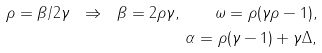<formula> <loc_0><loc_0><loc_500><loc_500>\rho = \beta / 2 \gamma \ \Rightarrow \ \beta = 2 \rho \gamma , \quad \omega = \rho ( \gamma \rho - 1 ) , \\ \alpha = \rho ( \gamma - 1 ) + \gamma \Delta ,</formula> 